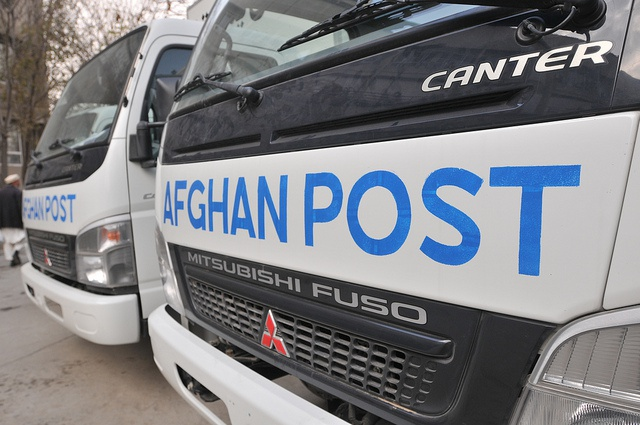Describe the objects in this image and their specific colors. I can see truck in gray, lightgray, black, and darkgray tones, truck in gray, darkgray, lightgray, and black tones, and people in gray, black, darkgray, and lightgray tones in this image. 